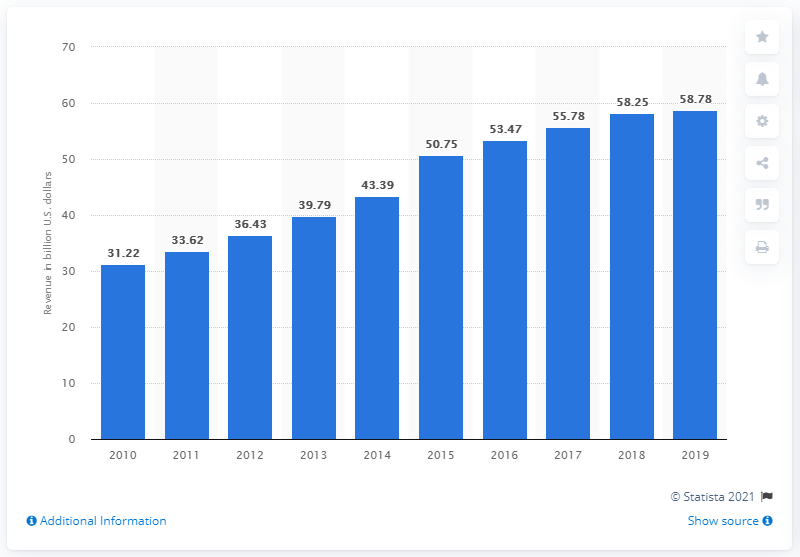Give some essential details in this illustration. In 2019, the revenue generated by cable and subscription-based programming was approximately 58.78. In 2019, cable and subscription-based programming generated approximately $58.78 in revenue. In the year 2010, the American cable and pay TV providers achieved the highest annual licensing revenue. 